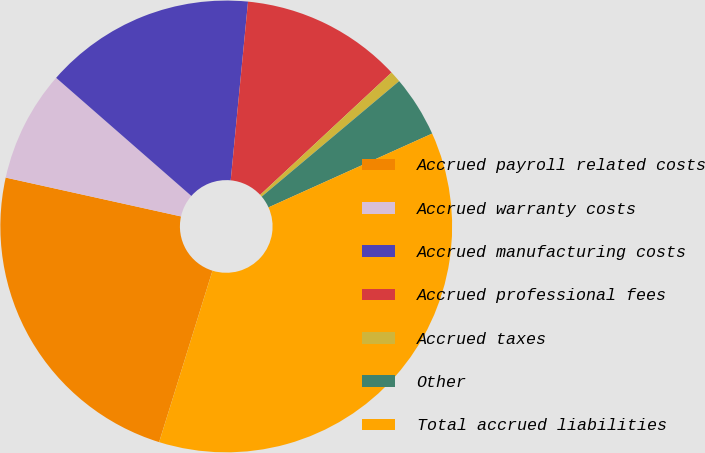Convert chart to OTSL. <chart><loc_0><loc_0><loc_500><loc_500><pie_chart><fcel>Accrued payroll related costs<fcel>Accrued warranty costs<fcel>Accrued manufacturing costs<fcel>Accrued professional fees<fcel>Accrued taxes<fcel>Other<fcel>Total accrued liabilities<nl><fcel>23.67%<fcel>7.96%<fcel>15.11%<fcel>11.53%<fcel>0.81%<fcel>4.38%<fcel>36.55%<nl></chart> 